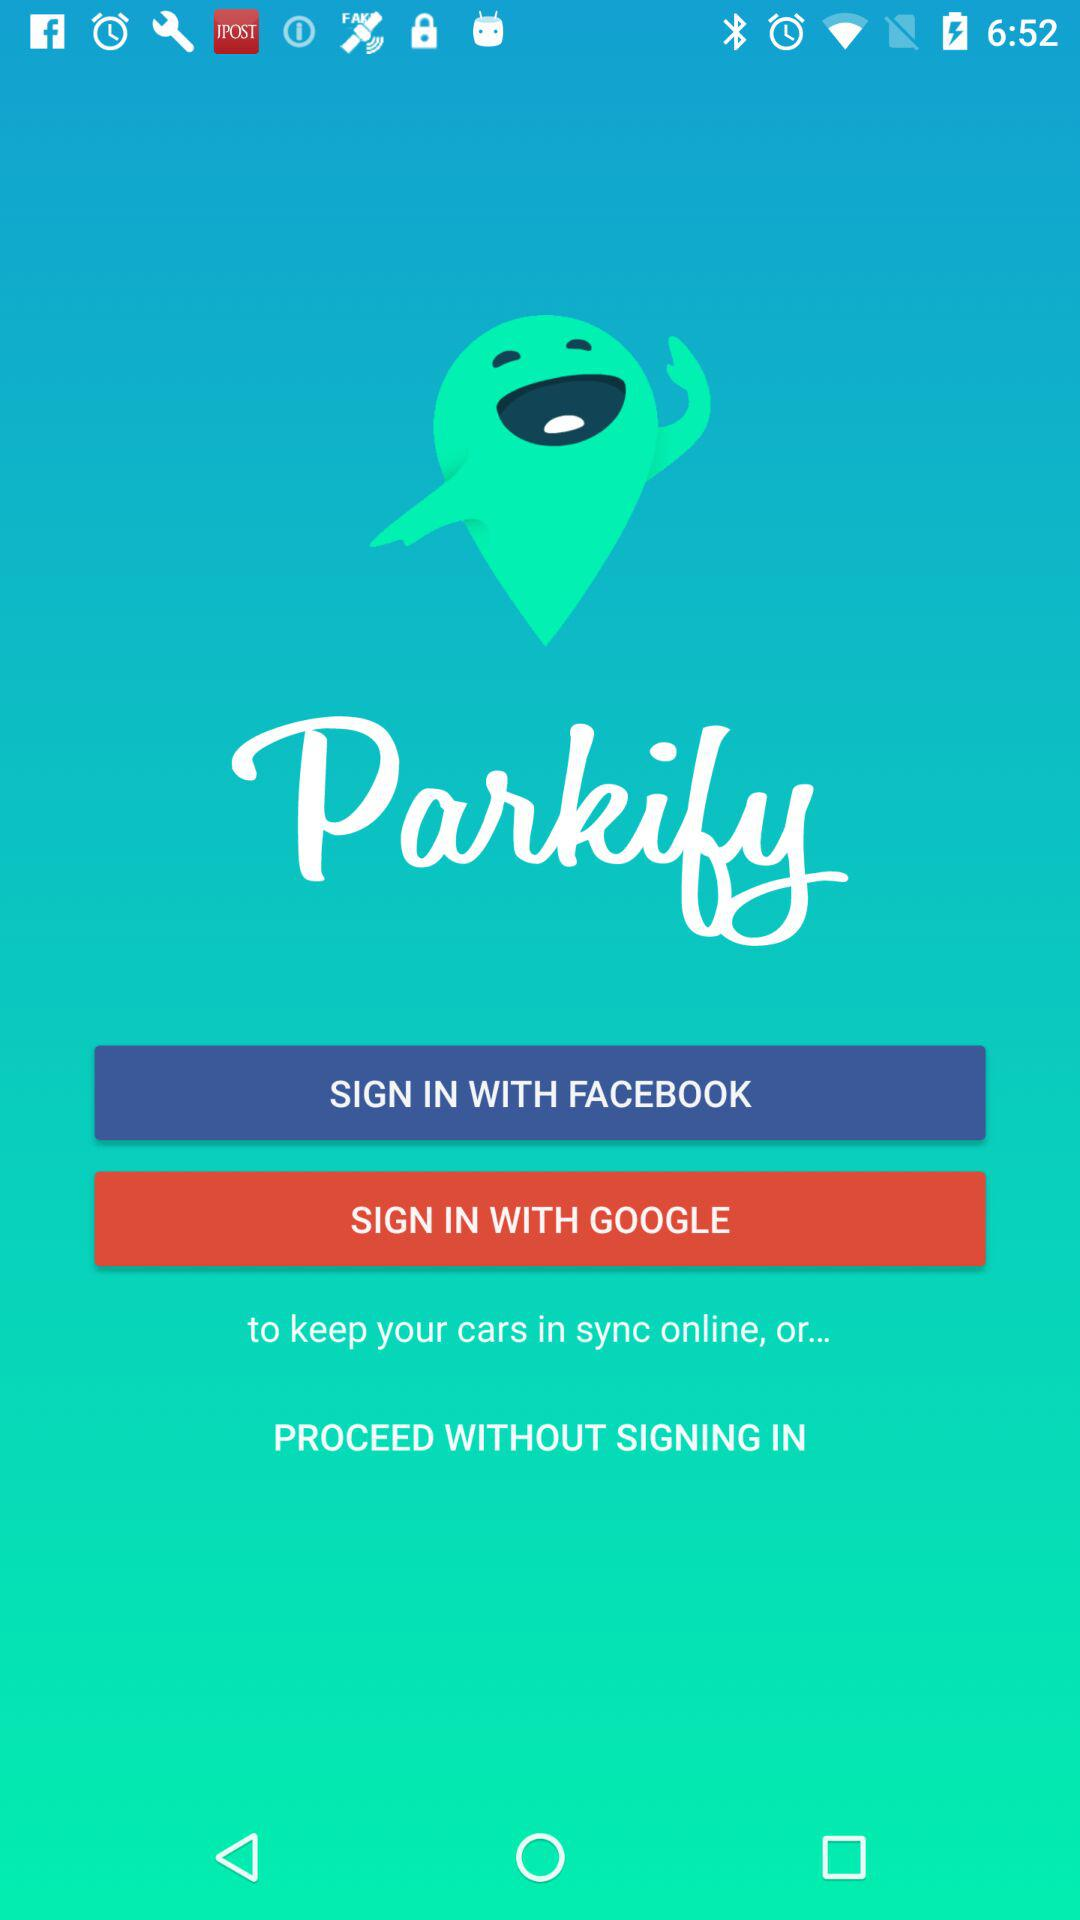What’s the app name? The app name is "Parkify". 